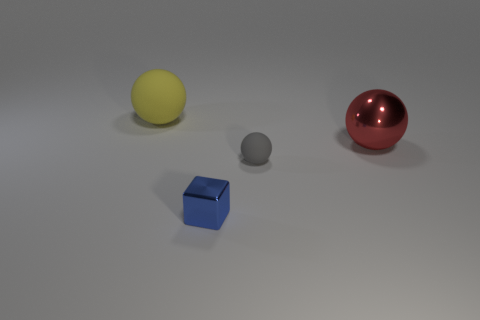What is the color of the thing that is both behind the blue metallic cube and in front of the red shiny thing?
Ensure brevity in your answer.  Gray. There is a rubber ball that is behind the gray matte ball; what number of red metal spheres are behind it?
Keep it short and to the point. 0. Is the big red shiny thing the same shape as the small gray matte object?
Your answer should be very brief. Yes. Is there anything else that has the same color as the small rubber object?
Your response must be concise. No. Does the small blue thing have the same shape as the metal thing that is behind the tiny matte object?
Give a very brief answer. No. There is a metal object on the left side of the rubber thing in front of the rubber ball left of the gray matte object; what is its color?
Provide a succinct answer. Blue. Are there any other things that are the same material as the tiny gray thing?
Ensure brevity in your answer.  Yes. There is a large thing left of the red metal sphere; is its shape the same as the big red object?
Offer a very short reply. Yes. What material is the yellow ball?
Ensure brevity in your answer.  Rubber. What shape is the metal object in front of the matte sphere right of the large yellow matte thing on the left side of the shiny cube?
Make the answer very short. Cube. 